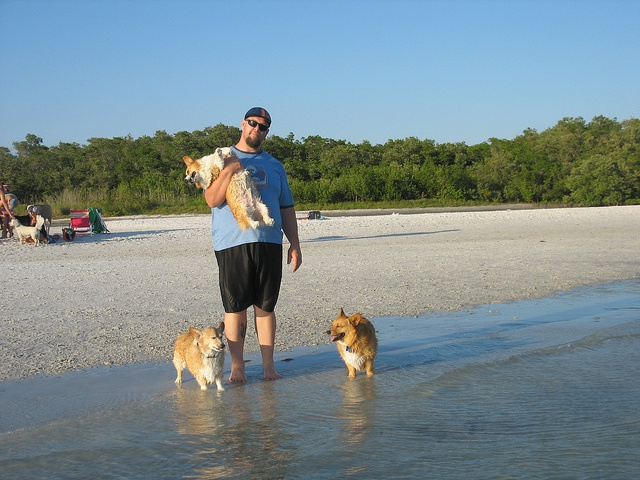Describe the objects in this image and their specific colors. I can see people in gray, black, blue, and tan tones, dog in gray, tan, and darkgray tones, dog in gray, tan, and beige tones, dog in gray, tan, olive, and maroon tones, and dog in gray, tan, and darkgray tones in this image. 